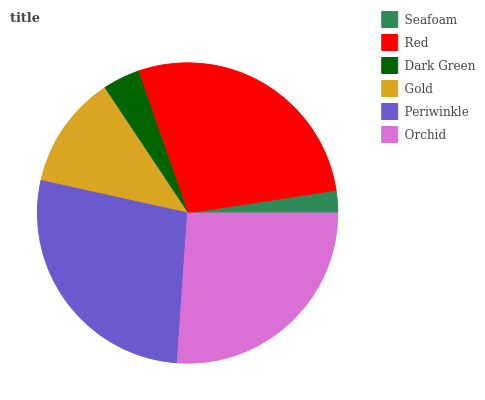Is Seafoam the minimum?
Answer yes or no. Yes. Is Red the maximum?
Answer yes or no. Yes. Is Dark Green the minimum?
Answer yes or no. No. Is Dark Green the maximum?
Answer yes or no. No. Is Red greater than Dark Green?
Answer yes or no. Yes. Is Dark Green less than Red?
Answer yes or no. Yes. Is Dark Green greater than Red?
Answer yes or no. No. Is Red less than Dark Green?
Answer yes or no. No. Is Orchid the high median?
Answer yes or no. Yes. Is Gold the low median?
Answer yes or no. Yes. Is Seafoam the high median?
Answer yes or no. No. Is Seafoam the low median?
Answer yes or no. No. 